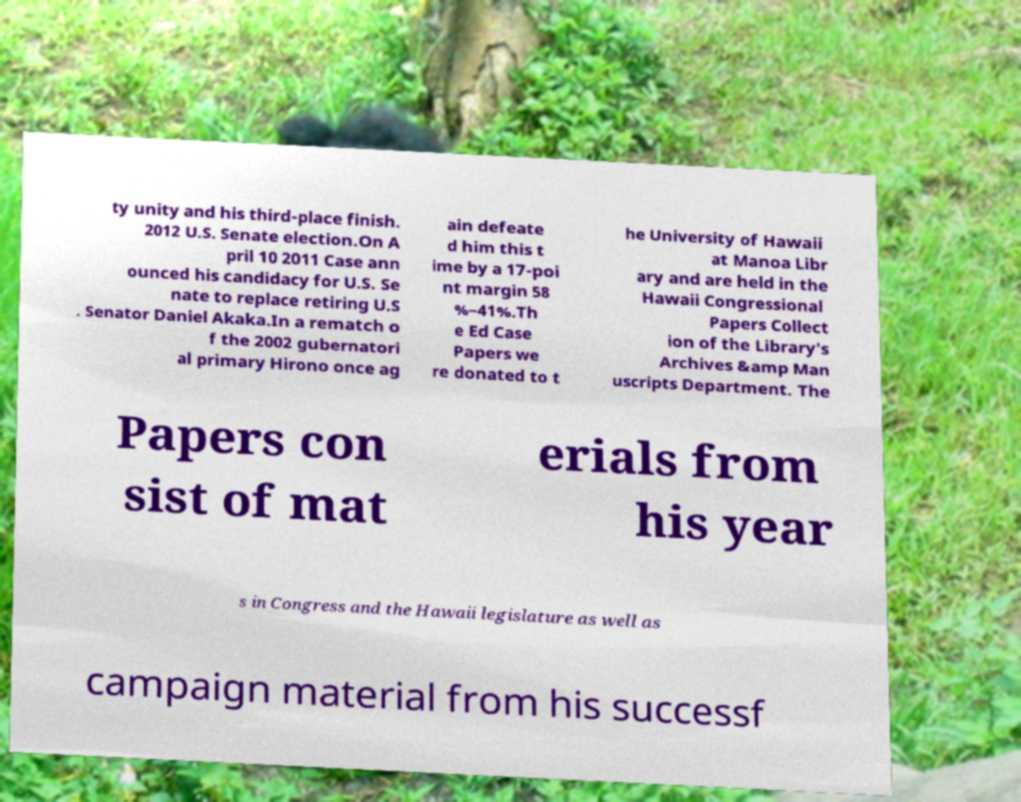I need the written content from this picture converted into text. Can you do that? ty unity and his third-place finish. 2012 U.S. Senate election.On A pril 10 2011 Case ann ounced his candidacy for U.S. Se nate to replace retiring U.S . Senator Daniel Akaka.In a rematch o f the 2002 gubernatori al primary Hirono once ag ain defeate d him this t ime by a 17-poi nt margin 58 %–41%.Th e Ed Case Papers we re donated to t he University of Hawaii at Manoa Libr ary and are held in the Hawaii Congressional Papers Collect ion of the Library's Archives &amp Man uscripts Department. The Papers con sist of mat erials from his year s in Congress and the Hawaii legislature as well as campaign material from his successf 